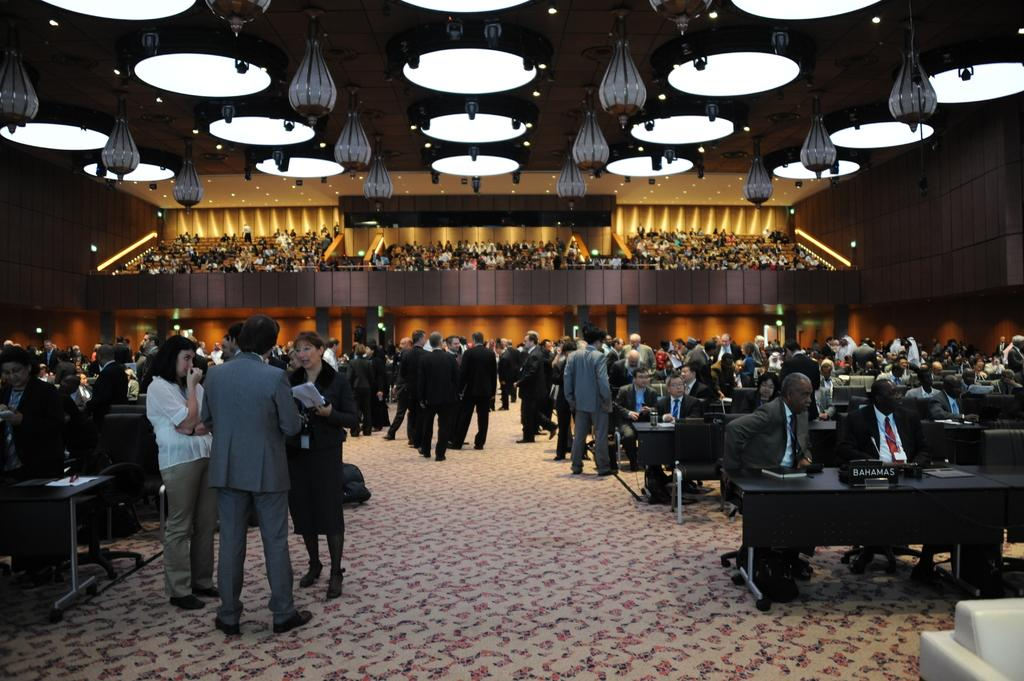What are the people in the image doing? There is a group of people sitting in chairs and a group of people standing in the image. What type of furniture is present in the image? There are tables and chairs in the image. What can be seen hanging from the ceiling in the image? There are lights in the image. What type of floor covering is visible in the image? There is a carpet in the image. What type of wine is being served at the scene in the image? There is no wine present in the image; it only shows a group of people sitting and standing, along with tables, chairs, lights, and a carpet. 